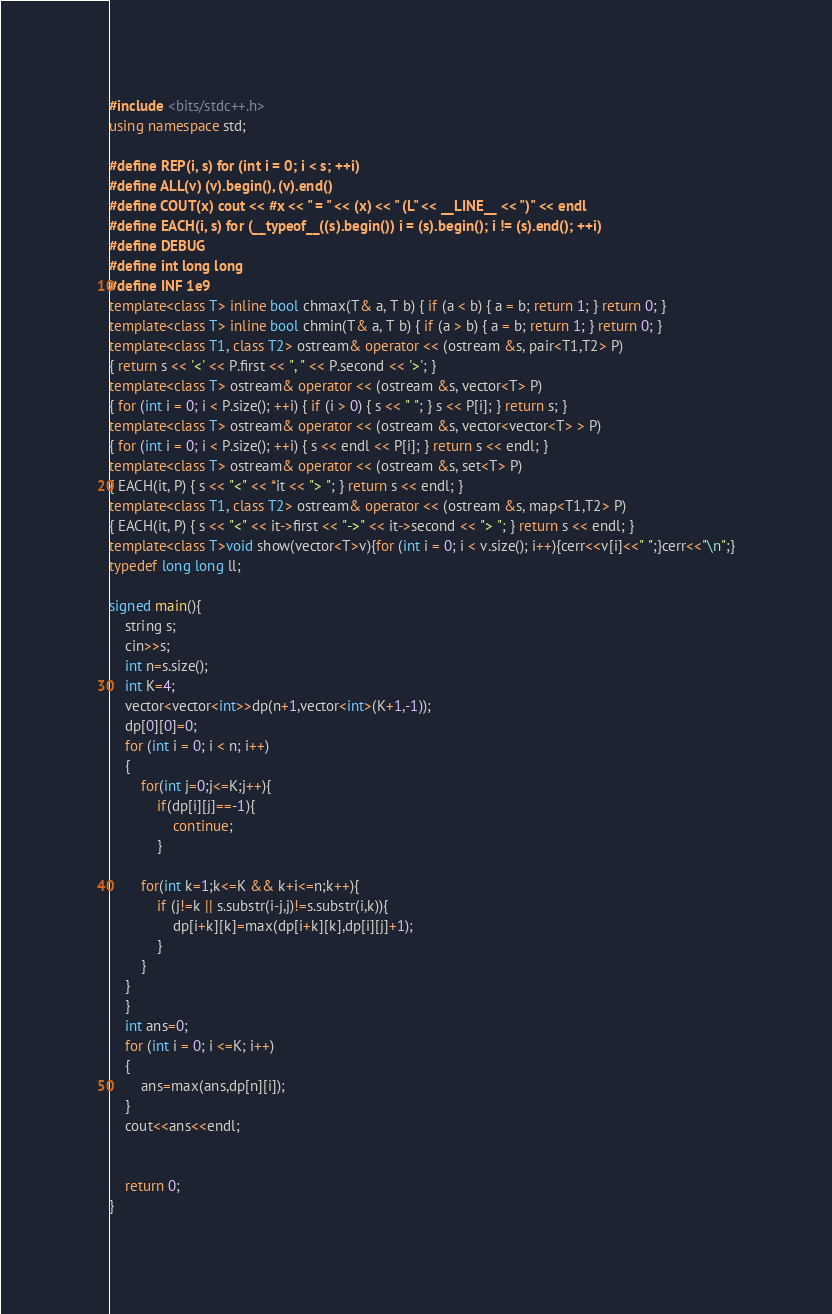<code> <loc_0><loc_0><loc_500><loc_500><_C++_>#include <bits/stdc++.h>
using namespace std;
 
#define REP(i, s) for (int i = 0; i < s; ++i)
#define ALL(v) (v).begin(), (v).end()
#define COUT(x) cout << #x << " = " << (x) << " (L" << __LINE__ << ")" << endl
#define EACH(i, s) for (__typeof__((s).begin()) i = (s).begin(); i != (s).end(); ++i)
#define DEBUG
#define int long long
#define INF 1e9
template<class T> inline bool chmax(T& a, T b) { if (a < b) { a = b; return 1; } return 0; }
template<class T> inline bool chmin(T& a, T b) { if (a > b) { a = b; return 1; } return 0; }
template<class T1, class T2> ostream& operator << (ostream &s, pair<T1,T2> P)
{ return s << '<' << P.first << ", " << P.second << '>'; }
template<class T> ostream& operator << (ostream &s, vector<T> P)
{ for (int i = 0; i < P.size(); ++i) { if (i > 0) { s << " "; } s << P[i]; } return s; }
template<class T> ostream& operator << (ostream &s, vector<vector<T> > P)
{ for (int i = 0; i < P.size(); ++i) { s << endl << P[i]; } return s << endl; }
template<class T> ostream& operator << (ostream &s, set<T> P)
{ EACH(it, P) { s << "<" << *it << "> "; } return s << endl; }
template<class T1, class T2> ostream& operator << (ostream &s, map<T1,T2> P)
{ EACH(it, P) { s << "<" << it->first << "->" << it->second << "> "; } return s << endl; }
template<class T>void show(vector<T>v){for (int i = 0; i < v.size(); i++){cerr<<v[i]<<" ";}cerr<<"\n";}
typedef long long ll;

signed main(){
    string s;
    cin>>s;
    int n=s.size();
    int K=4;
    vector<vector<int>>dp(n+1,vector<int>(K+1,-1));
    dp[0][0]=0;
    for (int i = 0; i < n; i++)
    {
        for(int j=0;j<=K;j++){
            if(dp[i][j]==-1){
                continue;
            }
        
        for(int k=1;k<=K && k+i<=n;k++){
            if (j!=k || s.substr(i-j,j)!=s.substr(i,k)){
                dp[i+k][k]=max(dp[i+k][k],dp[i][j]+1);
            }
        }
    }
    }
    int ans=0;
    for (int i = 0; i <=K; i++)
    {
        ans=max(ans,dp[n][i]);
    }
    cout<<ans<<endl;
    

    return 0;
}</code> 